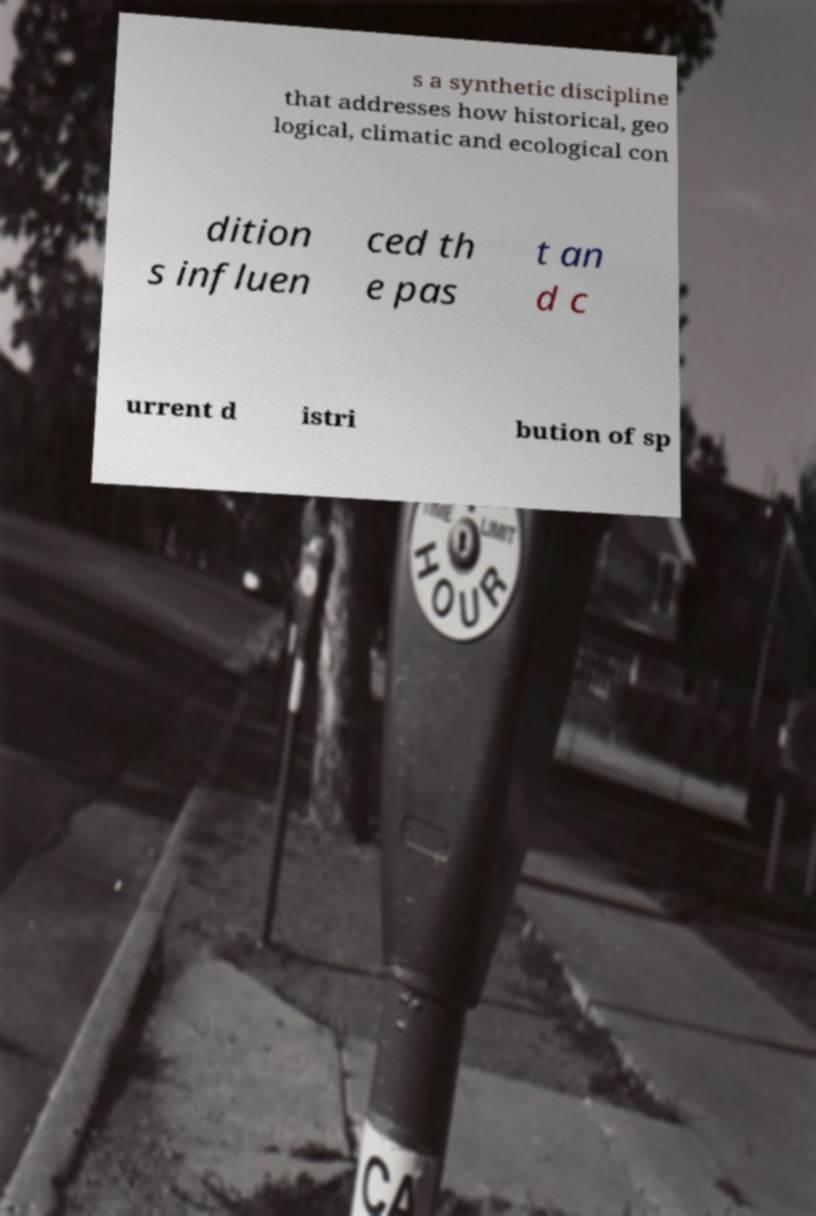There's text embedded in this image that I need extracted. Can you transcribe it verbatim? s a synthetic discipline that addresses how historical, geo logical, climatic and ecological con dition s influen ced th e pas t an d c urrent d istri bution of sp 